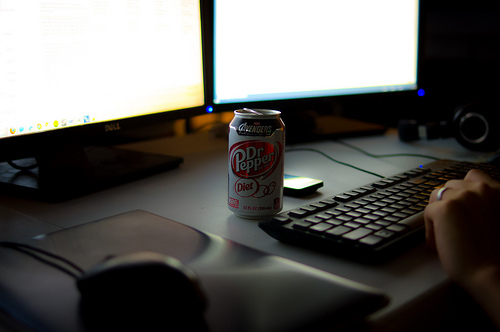<image>
Can you confirm if the monitor is on the stand? No. The monitor is not positioned on the stand. They may be near each other, but the monitor is not supported by or resting on top of the stand. 